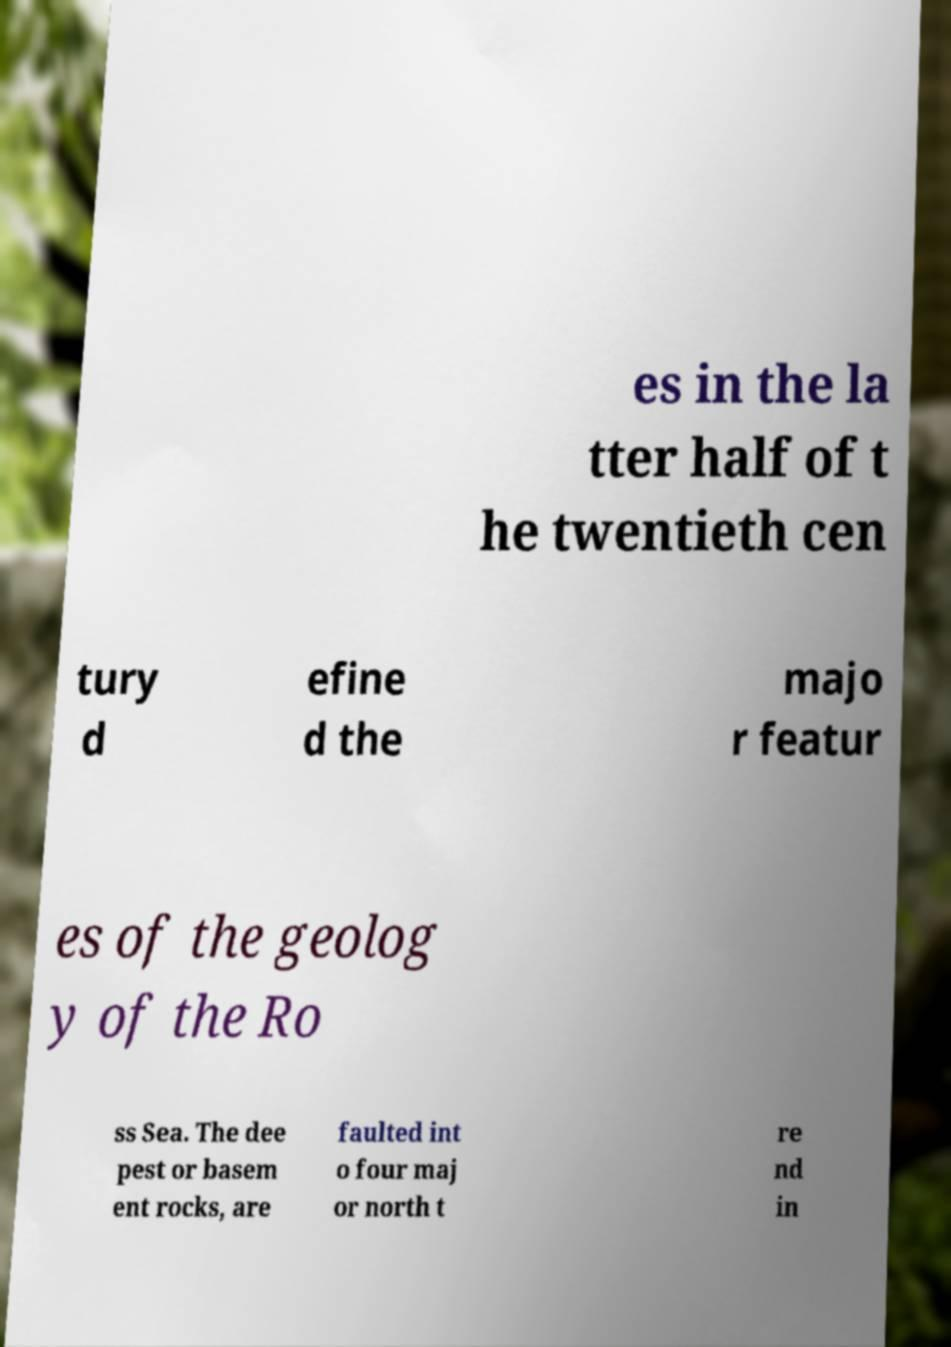Could you extract and type out the text from this image? es in the la tter half of t he twentieth cen tury d efine d the majo r featur es of the geolog y of the Ro ss Sea. The dee pest or basem ent rocks, are faulted int o four maj or north t re nd in 